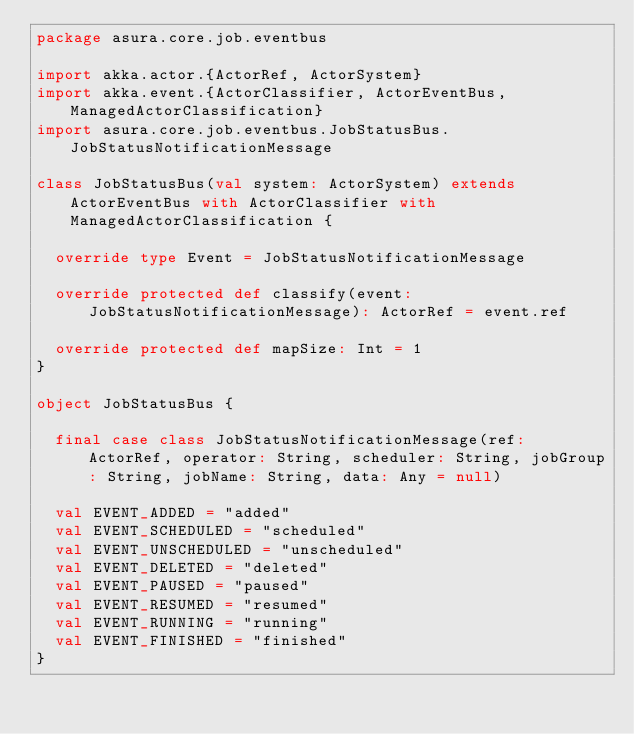<code> <loc_0><loc_0><loc_500><loc_500><_Scala_>package asura.core.job.eventbus

import akka.actor.{ActorRef, ActorSystem}
import akka.event.{ActorClassifier, ActorEventBus, ManagedActorClassification}
import asura.core.job.eventbus.JobStatusBus.JobStatusNotificationMessage

class JobStatusBus(val system: ActorSystem) extends ActorEventBus with ActorClassifier with ManagedActorClassification {

  override type Event = JobStatusNotificationMessage

  override protected def classify(event: JobStatusNotificationMessage): ActorRef = event.ref

  override protected def mapSize: Int = 1
}

object JobStatusBus {

  final case class JobStatusNotificationMessage(ref: ActorRef, operator: String, scheduler: String, jobGroup: String, jobName: String, data: Any = null)

  val EVENT_ADDED = "added"
  val EVENT_SCHEDULED = "scheduled"
  val EVENT_UNSCHEDULED = "unscheduled"
  val EVENT_DELETED = "deleted"
  val EVENT_PAUSED = "paused"
  val EVENT_RESUMED = "resumed"
  val EVENT_RUNNING = "running"
  val EVENT_FINISHED = "finished"
}
</code> 